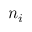Convert formula to latex. <formula><loc_0><loc_0><loc_500><loc_500>n _ { i }</formula> 